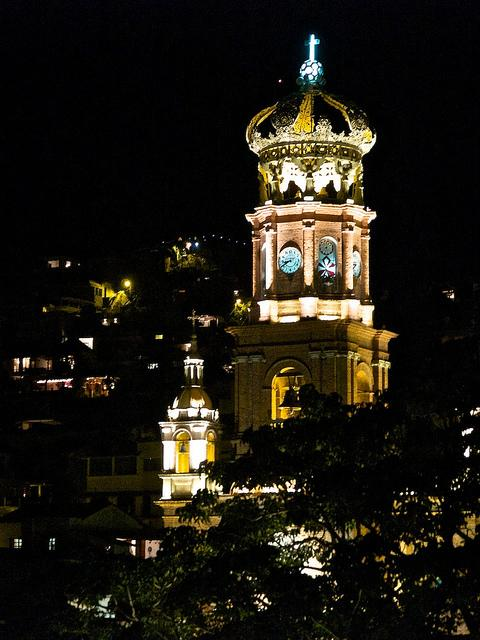What is on the top of the building? cross 